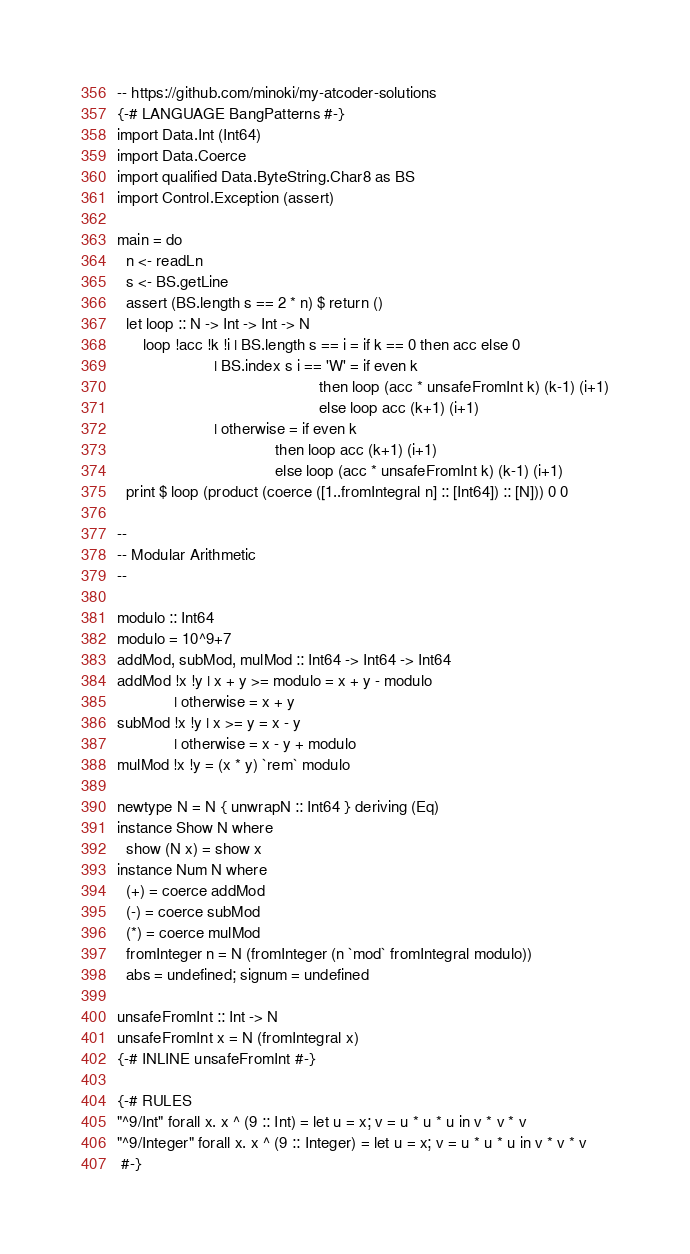Convert code to text. <code><loc_0><loc_0><loc_500><loc_500><_Haskell_>-- https://github.com/minoki/my-atcoder-solutions
{-# LANGUAGE BangPatterns #-}
import Data.Int (Int64)
import Data.Coerce
import qualified Data.ByteString.Char8 as BS
import Control.Exception (assert)

main = do
  n <- readLn
  s <- BS.getLine
  assert (BS.length s == 2 * n) $ return ()
  let loop :: N -> Int -> Int -> N
      loop !acc !k !i | BS.length s == i = if k == 0 then acc else 0
                      | BS.index s i == 'W' = if even k
                                              then loop (acc * unsafeFromInt k) (k-1) (i+1)
                                              else loop acc (k+1) (i+1)
                      | otherwise = if even k
                                    then loop acc (k+1) (i+1)
                                    else loop (acc * unsafeFromInt k) (k-1) (i+1)
  print $ loop (product (coerce ([1..fromIntegral n] :: [Int64]) :: [N])) 0 0

--
-- Modular Arithmetic
--

modulo :: Int64
modulo = 10^9+7
addMod, subMod, mulMod :: Int64 -> Int64 -> Int64
addMod !x !y | x + y >= modulo = x + y - modulo
             | otherwise = x + y
subMod !x !y | x >= y = x - y
             | otherwise = x - y + modulo
mulMod !x !y = (x * y) `rem` modulo

newtype N = N { unwrapN :: Int64 } deriving (Eq)
instance Show N where
  show (N x) = show x
instance Num N where
  (+) = coerce addMod
  (-) = coerce subMod
  (*) = coerce mulMod
  fromInteger n = N (fromInteger (n `mod` fromIntegral modulo))
  abs = undefined; signum = undefined

unsafeFromInt :: Int -> N
unsafeFromInt x = N (fromIntegral x)
{-# INLINE unsafeFromInt #-}

{-# RULES
"^9/Int" forall x. x ^ (9 :: Int) = let u = x; v = u * u * u in v * v * v
"^9/Integer" forall x. x ^ (9 :: Integer) = let u = x; v = u * u * u in v * v * v
 #-}
</code> 